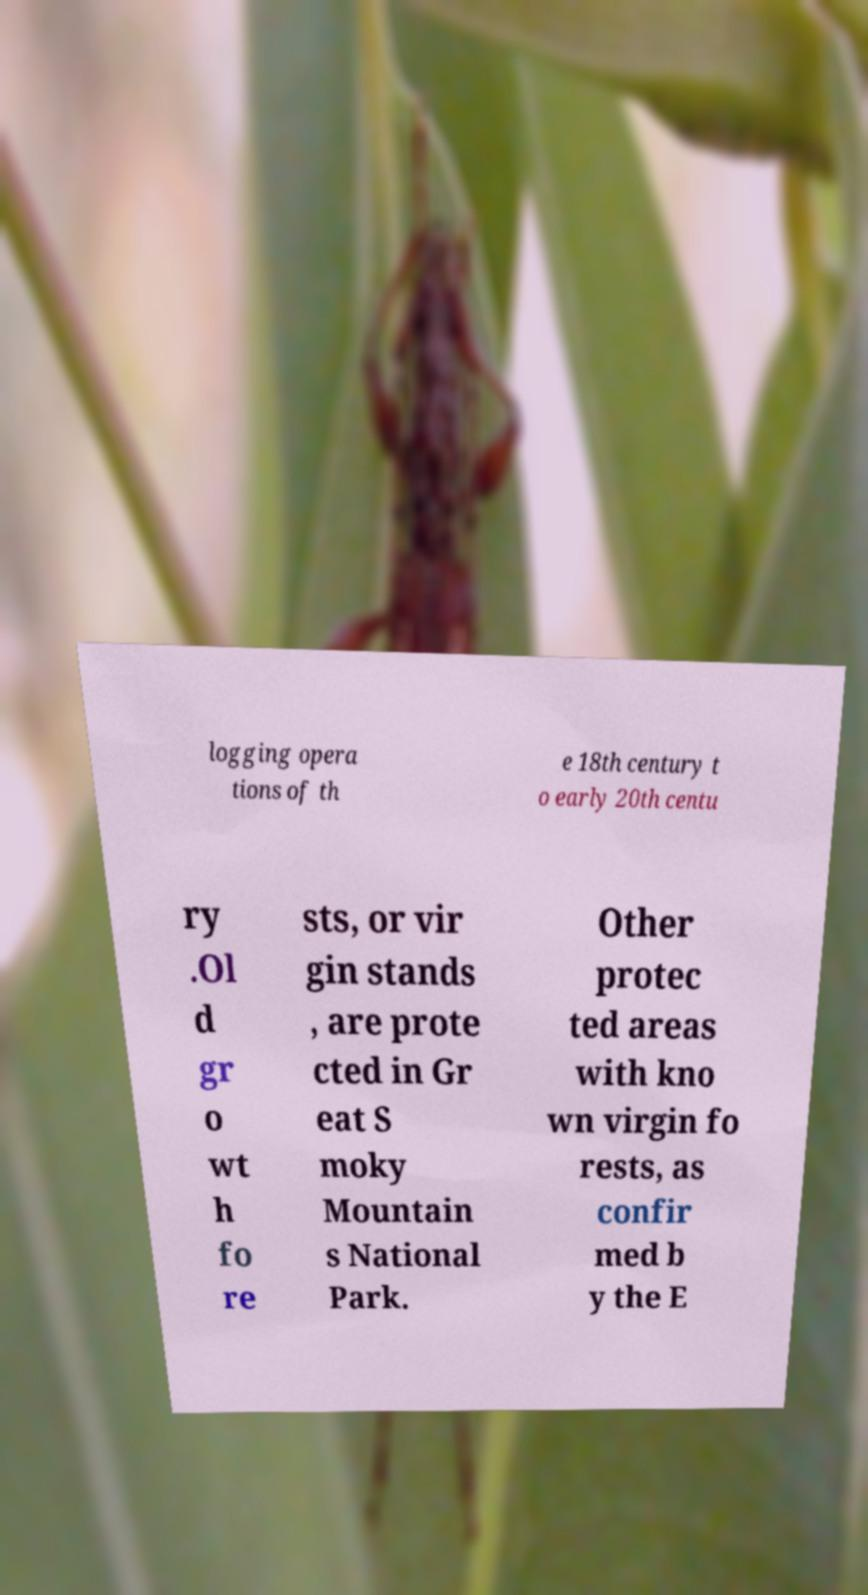Could you extract and type out the text from this image? logging opera tions of th e 18th century t o early 20th centu ry .Ol d gr o wt h fo re sts, or vir gin stands , are prote cted in Gr eat S moky Mountain s National Park. Other protec ted areas with kno wn virgin fo rests, as confir med b y the E 